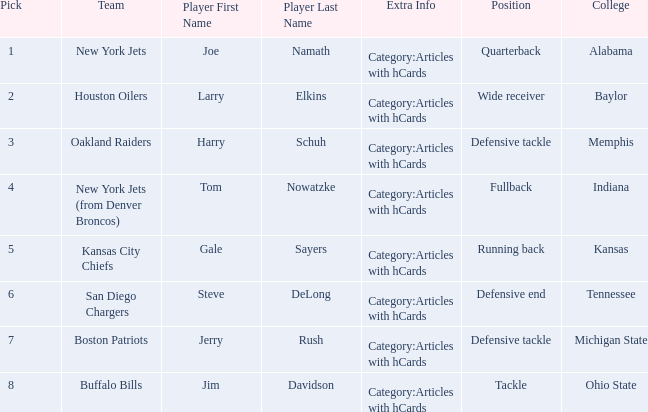Which player is from the College of Alabama? Joe Namath Category:Articles with hCards. 